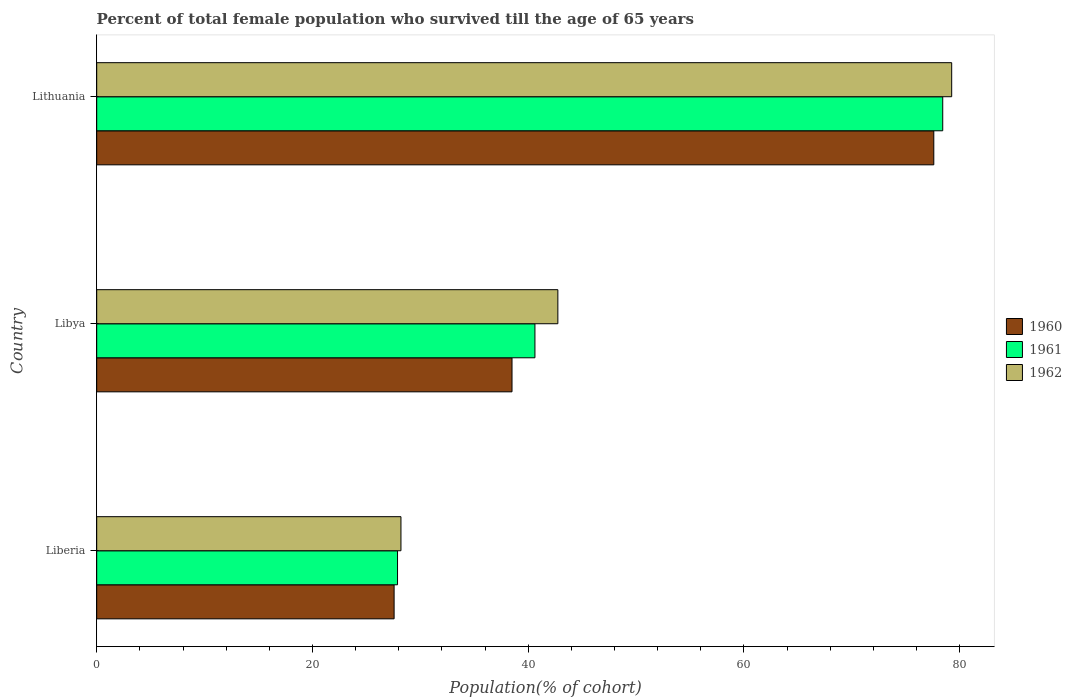How many different coloured bars are there?
Your response must be concise. 3. How many groups of bars are there?
Provide a succinct answer. 3. Are the number of bars on each tick of the Y-axis equal?
Your answer should be compact. Yes. How many bars are there on the 3rd tick from the top?
Offer a terse response. 3. What is the label of the 2nd group of bars from the top?
Your answer should be very brief. Libya. In how many cases, is the number of bars for a given country not equal to the number of legend labels?
Offer a very short reply. 0. What is the percentage of total female population who survived till the age of 65 years in 1962 in Libya?
Make the answer very short. 42.75. Across all countries, what is the maximum percentage of total female population who survived till the age of 65 years in 1960?
Offer a terse response. 77.6. Across all countries, what is the minimum percentage of total female population who survived till the age of 65 years in 1960?
Offer a very short reply. 27.57. In which country was the percentage of total female population who survived till the age of 65 years in 1960 maximum?
Offer a very short reply. Lithuania. In which country was the percentage of total female population who survived till the age of 65 years in 1962 minimum?
Offer a very short reply. Liberia. What is the total percentage of total female population who survived till the age of 65 years in 1961 in the graph?
Provide a short and direct response. 146.93. What is the difference between the percentage of total female population who survived till the age of 65 years in 1962 in Liberia and that in Libya?
Give a very brief answer. -14.55. What is the difference between the percentage of total female population who survived till the age of 65 years in 1960 in Liberia and the percentage of total female population who survived till the age of 65 years in 1961 in Libya?
Keep it short and to the point. -13.05. What is the average percentage of total female population who survived till the age of 65 years in 1961 per country?
Give a very brief answer. 48.98. What is the difference between the percentage of total female population who survived till the age of 65 years in 1961 and percentage of total female population who survived till the age of 65 years in 1960 in Libya?
Provide a succinct answer. 2.12. What is the ratio of the percentage of total female population who survived till the age of 65 years in 1962 in Libya to that in Lithuania?
Provide a short and direct response. 0.54. Is the percentage of total female population who survived till the age of 65 years in 1960 in Liberia less than that in Libya?
Your answer should be very brief. Yes. What is the difference between the highest and the second highest percentage of total female population who survived till the age of 65 years in 1960?
Ensure brevity in your answer.  39.1. What is the difference between the highest and the lowest percentage of total female population who survived till the age of 65 years in 1962?
Provide a succinct answer. 51.05. What does the 2nd bar from the bottom in Liberia represents?
Make the answer very short. 1961. How many countries are there in the graph?
Provide a short and direct response. 3. What is the difference between two consecutive major ticks on the X-axis?
Your response must be concise. 20. Are the values on the major ticks of X-axis written in scientific E-notation?
Offer a very short reply. No. Does the graph contain any zero values?
Your answer should be compact. No. How are the legend labels stacked?
Ensure brevity in your answer.  Vertical. What is the title of the graph?
Ensure brevity in your answer.  Percent of total female population who survived till the age of 65 years. What is the label or title of the X-axis?
Your answer should be very brief. Population(% of cohort). What is the Population(% of cohort) in 1960 in Liberia?
Make the answer very short. 27.57. What is the Population(% of cohort) of 1961 in Liberia?
Ensure brevity in your answer.  27.89. What is the Population(% of cohort) of 1962 in Liberia?
Your answer should be very brief. 28.2. What is the Population(% of cohort) of 1960 in Libya?
Give a very brief answer. 38.5. What is the Population(% of cohort) of 1961 in Libya?
Offer a terse response. 40.62. What is the Population(% of cohort) of 1962 in Libya?
Give a very brief answer. 42.75. What is the Population(% of cohort) of 1960 in Lithuania?
Your answer should be compact. 77.6. What is the Population(% of cohort) of 1961 in Lithuania?
Provide a short and direct response. 78.43. What is the Population(% of cohort) of 1962 in Lithuania?
Provide a succinct answer. 79.25. Across all countries, what is the maximum Population(% of cohort) of 1960?
Offer a terse response. 77.6. Across all countries, what is the maximum Population(% of cohort) in 1961?
Your response must be concise. 78.43. Across all countries, what is the maximum Population(% of cohort) of 1962?
Your response must be concise. 79.25. Across all countries, what is the minimum Population(% of cohort) of 1960?
Offer a terse response. 27.57. Across all countries, what is the minimum Population(% of cohort) in 1961?
Keep it short and to the point. 27.89. Across all countries, what is the minimum Population(% of cohort) in 1962?
Ensure brevity in your answer.  28.2. What is the total Population(% of cohort) of 1960 in the graph?
Provide a short and direct response. 143.66. What is the total Population(% of cohort) of 1961 in the graph?
Keep it short and to the point. 146.93. What is the total Population(% of cohort) of 1962 in the graph?
Offer a very short reply. 150.2. What is the difference between the Population(% of cohort) in 1960 in Liberia and that in Libya?
Keep it short and to the point. -10.93. What is the difference between the Population(% of cohort) of 1961 in Liberia and that in Libya?
Keep it short and to the point. -12.74. What is the difference between the Population(% of cohort) of 1962 in Liberia and that in Libya?
Provide a succinct answer. -14.55. What is the difference between the Population(% of cohort) of 1960 in Liberia and that in Lithuania?
Provide a short and direct response. -50.03. What is the difference between the Population(% of cohort) of 1961 in Liberia and that in Lithuania?
Your answer should be compact. -50.54. What is the difference between the Population(% of cohort) of 1962 in Liberia and that in Lithuania?
Your answer should be compact. -51.05. What is the difference between the Population(% of cohort) in 1960 in Libya and that in Lithuania?
Your response must be concise. -39.1. What is the difference between the Population(% of cohort) in 1961 in Libya and that in Lithuania?
Provide a short and direct response. -37.8. What is the difference between the Population(% of cohort) in 1962 in Libya and that in Lithuania?
Offer a very short reply. -36.51. What is the difference between the Population(% of cohort) of 1960 in Liberia and the Population(% of cohort) of 1961 in Libya?
Your answer should be compact. -13.05. What is the difference between the Population(% of cohort) of 1960 in Liberia and the Population(% of cohort) of 1962 in Libya?
Your answer should be very brief. -15.18. What is the difference between the Population(% of cohort) of 1961 in Liberia and the Population(% of cohort) of 1962 in Libya?
Your response must be concise. -14.86. What is the difference between the Population(% of cohort) in 1960 in Liberia and the Population(% of cohort) in 1961 in Lithuania?
Give a very brief answer. -50.86. What is the difference between the Population(% of cohort) of 1960 in Liberia and the Population(% of cohort) of 1962 in Lithuania?
Your answer should be compact. -51.69. What is the difference between the Population(% of cohort) in 1961 in Liberia and the Population(% of cohort) in 1962 in Lithuania?
Provide a short and direct response. -51.37. What is the difference between the Population(% of cohort) in 1960 in Libya and the Population(% of cohort) in 1961 in Lithuania?
Offer a terse response. -39.93. What is the difference between the Population(% of cohort) in 1960 in Libya and the Population(% of cohort) in 1962 in Lithuania?
Give a very brief answer. -40.76. What is the difference between the Population(% of cohort) in 1961 in Libya and the Population(% of cohort) in 1962 in Lithuania?
Give a very brief answer. -38.63. What is the average Population(% of cohort) of 1960 per country?
Make the answer very short. 47.89. What is the average Population(% of cohort) in 1961 per country?
Provide a short and direct response. 48.98. What is the average Population(% of cohort) of 1962 per country?
Offer a very short reply. 50.07. What is the difference between the Population(% of cohort) of 1960 and Population(% of cohort) of 1961 in Liberia?
Give a very brief answer. -0.32. What is the difference between the Population(% of cohort) in 1960 and Population(% of cohort) in 1962 in Liberia?
Provide a succinct answer. -0.63. What is the difference between the Population(% of cohort) of 1961 and Population(% of cohort) of 1962 in Liberia?
Offer a terse response. -0.32. What is the difference between the Population(% of cohort) of 1960 and Population(% of cohort) of 1961 in Libya?
Offer a terse response. -2.12. What is the difference between the Population(% of cohort) of 1960 and Population(% of cohort) of 1962 in Libya?
Your answer should be very brief. -4.25. What is the difference between the Population(% of cohort) of 1961 and Population(% of cohort) of 1962 in Libya?
Ensure brevity in your answer.  -2.12. What is the difference between the Population(% of cohort) in 1960 and Population(% of cohort) in 1961 in Lithuania?
Make the answer very short. -0.83. What is the difference between the Population(% of cohort) in 1960 and Population(% of cohort) in 1962 in Lithuania?
Offer a terse response. -1.66. What is the difference between the Population(% of cohort) in 1961 and Population(% of cohort) in 1962 in Lithuania?
Your response must be concise. -0.83. What is the ratio of the Population(% of cohort) of 1960 in Liberia to that in Libya?
Offer a very short reply. 0.72. What is the ratio of the Population(% of cohort) of 1961 in Liberia to that in Libya?
Make the answer very short. 0.69. What is the ratio of the Population(% of cohort) of 1962 in Liberia to that in Libya?
Give a very brief answer. 0.66. What is the ratio of the Population(% of cohort) of 1960 in Liberia to that in Lithuania?
Give a very brief answer. 0.36. What is the ratio of the Population(% of cohort) in 1961 in Liberia to that in Lithuania?
Your answer should be compact. 0.36. What is the ratio of the Population(% of cohort) of 1962 in Liberia to that in Lithuania?
Provide a succinct answer. 0.36. What is the ratio of the Population(% of cohort) in 1960 in Libya to that in Lithuania?
Your answer should be compact. 0.5. What is the ratio of the Population(% of cohort) in 1961 in Libya to that in Lithuania?
Keep it short and to the point. 0.52. What is the ratio of the Population(% of cohort) in 1962 in Libya to that in Lithuania?
Keep it short and to the point. 0.54. What is the difference between the highest and the second highest Population(% of cohort) in 1960?
Give a very brief answer. 39.1. What is the difference between the highest and the second highest Population(% of cohort) in 1961?
Offer a terse response. 37.8. What is the difference between the highest and the second highest Population(% of cohort) of 1962?
Offer a very short reply. 36.51. What is the difference between the highest and the lowest Population(% of cohort) in 1960?
Your response must be concise. 50.03. What is the difference between the highest and the lowest Population(% of cohort) in 1961?
Offer a terse response. 50.54. What is the difference between the highest and the lowest Population(% of cohort) of 1962?
Offer a very short reply. 51.05. 